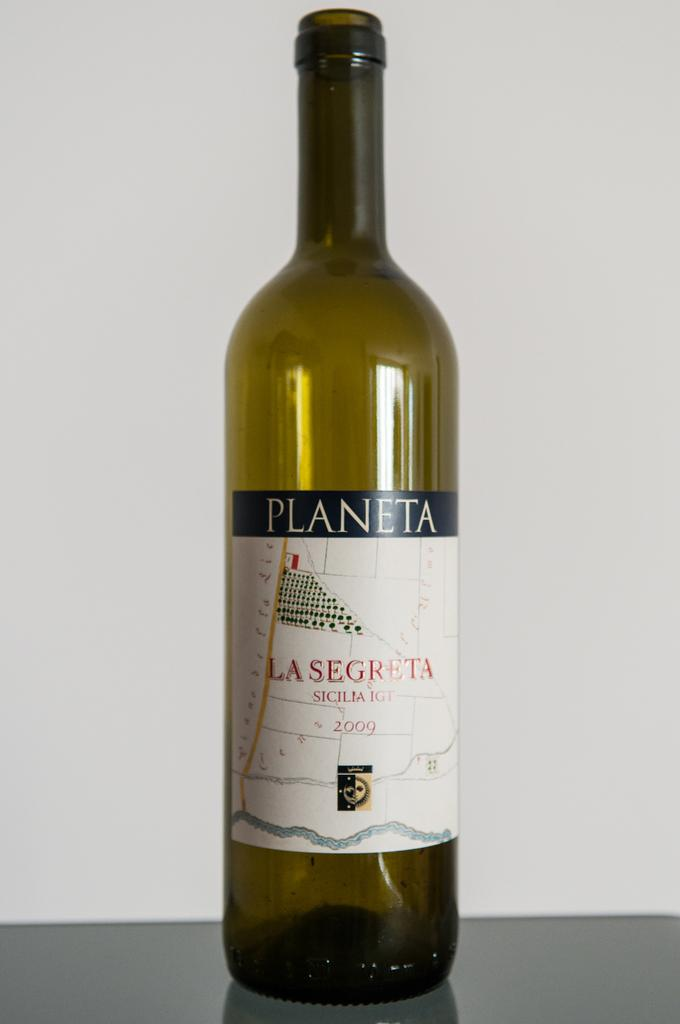<image>
Create a compact narrative representing the image presented. A glass bottle of La Segreta wine is sitting on a table. 